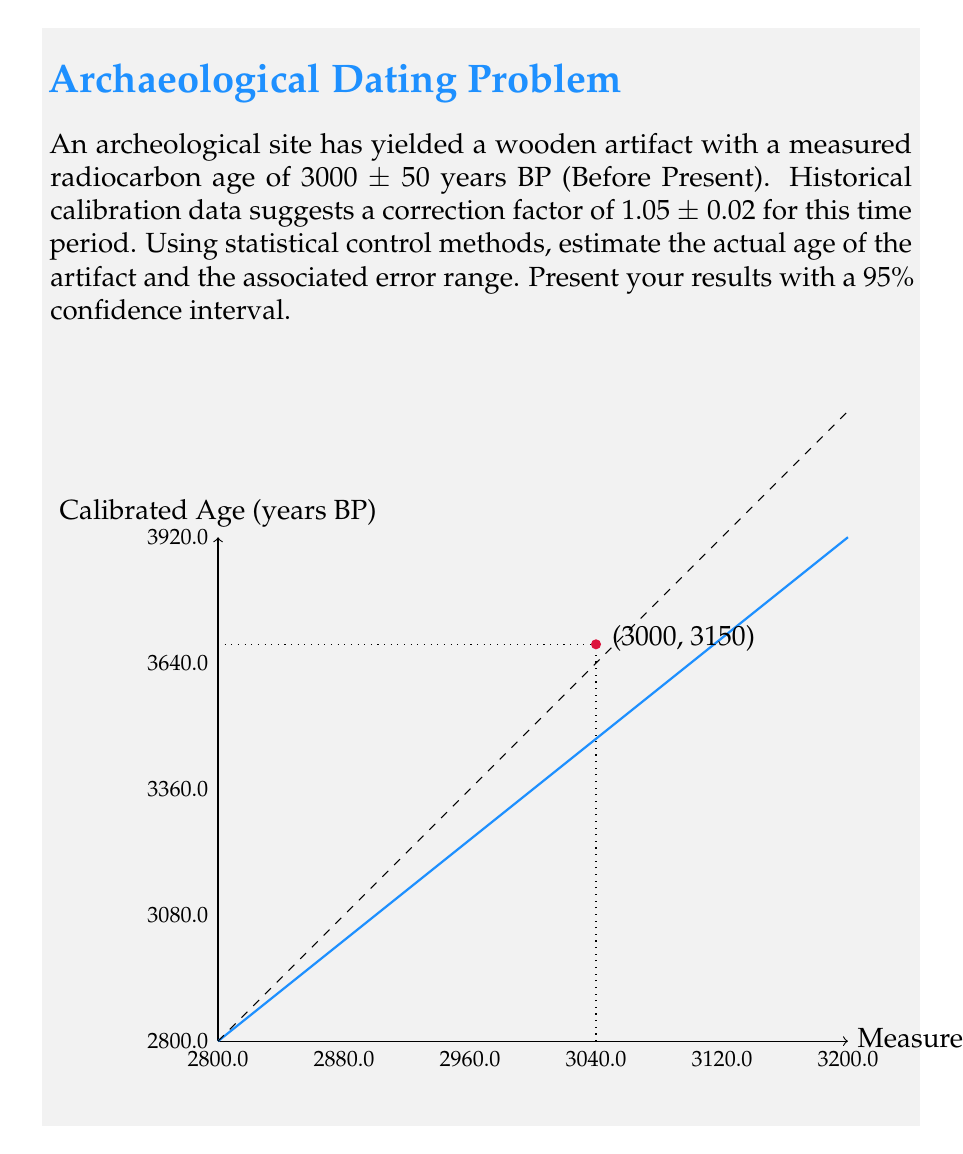Can you solve this math problem? Let's approach this step-by-step:

1) The measured radiocarbon age is 3000 ± 50 years BP. This can be represented as a normal distribution with mean μ = 3000 and standard deviation σ = 50.

2) The correction factor is 1.05 ± 0.02. This can also be represented as a normal distribution with mean μ_cf = 1.05 and standard deviation σ_cf = 0.02.

3) To estimate the actual age, we multiply the measured age by the correction factor:

   Actual Age = Measured Age × Correction Factor
   
   $$ E[Actual Age] = E[Measured Age] \times E[Correction Factor] = 3000 \times 1.05 = 3150 \text{ years BP} $$

4) To calculate the error range, we need to consider the propagation of errors. The variance of the product of two independent random variables X and Y is given by:

   $$ Var(XY) = (E[X])^2 Var(Y) + (E[Y])^2 Var(X) + Var(X)Var(Y) $$

5) Applying this to our case:

   $$ \begin{align*}
   Var(Actual Age) &= (3000)^2 (0.02)^2 + (1.05)^2 (50)^2 + (50)^2 (0.02)^2 \\
   &= 3600 + 2756.25 + 1 \\
   &= 6357.25
   \end{align*} $$

6) The standard deviation of the actual age is therefore:

   $$ \sigma_{Actual Age} = \sqrt{6357.25} \approx 79.73 \text{ years} $$

7) For a 95% confidence interval, we use ±1.96σ:

   $$ 3150 \pm (1.96 \times 79.73) \approx 3150 \pm 156 \text{ years BP} $$
Answer: 3150 ± 156 years BP (95% CI) 